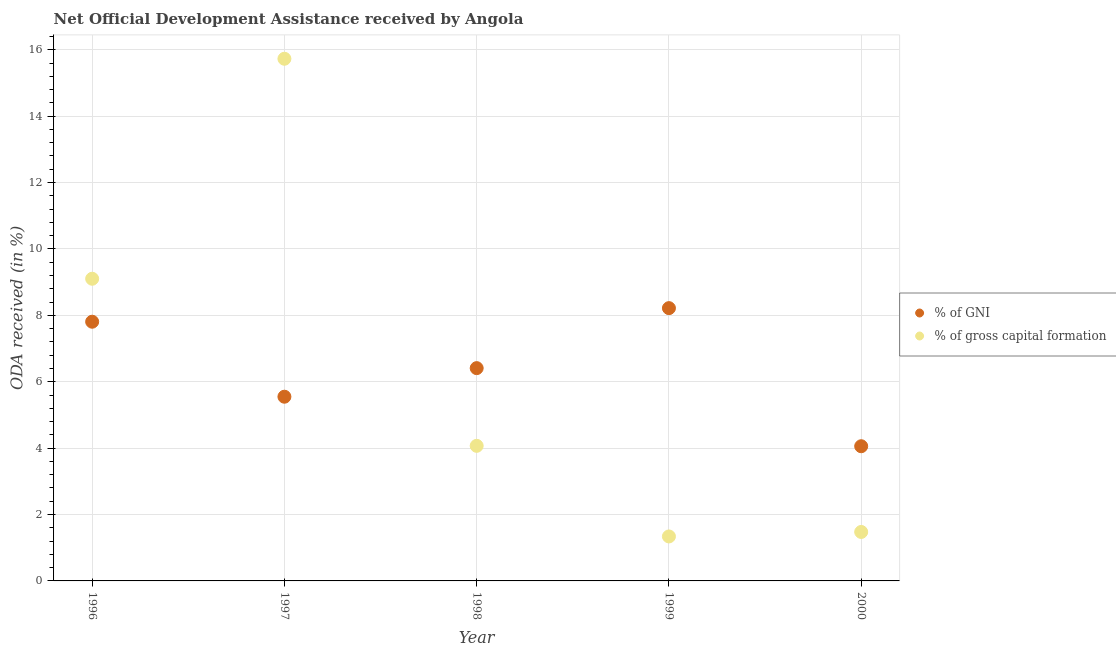What is the oda received as percentage of gross capital formation in 1996?
Provide a short and direct response. 9.1. Across all years, what is the maximum oda received as percentage of gni?
Offer a terse response. 8.22. Across all years, what is the minimum oda received as percentage of gni?
Offer a very short reply. 4.06. What is the total oda received as percentage of gni in the graph?
Keep it short and to the point. 32.04. What is the difference between the oda received as percentage of gni in 1998 and that in 1999?
Offer a very short reply. -1.81. What is the difference between the oda received as percentage of gross capital formation in 1997 and the oda received as percentage of gni in 1999?
Your answer should be compact. 7.51. What is the average oda received as percentage of gni per year?
Offer a terse response. 6.41. In the year 1998, what is the difference between the oda received as percentage of gni and oda received as percentage of gross capital formation?
Ensure brevity in your answer.  2.34. What is the ratio of the oda received as percentage of gni in 1998 to that in 1999?
Give a very brief answer. 0.78. What is the difference between the highest and the second highest oda received as percentage of gross capital formation?
Keep it short and to the point. 6.63. What is the difference between the highest and the lowest oda received as percentage of gni?
Provide a short and direct response. 4.16. In how many years, is the oda received as percentage of gross capital formation greater than the average oda received as percentage of gross capital formation taken over all years?
Your answer should be compact. 2. Is the oda received as percentage of gni strictly greater than the oda received as percentage of gross capital formation over the years?
Your answer should be very brief. No. How many years are there in the graph?
Your answer should be very brief. 5. Does the graph contain grids?
Your answer should be compact. Yes. How many legend labels are there?
Your response must be concise. 2. What is the title of the graph?
Offer a very short reply. Net Official Development Assistance received by Angola. What is the label or title of the X-axis?
Your response must be concise. Year. What is the label or title of the Y-axis?
Make the answer very short. ODA received (in %). What is the ODA received (in %) of % of GNI in 1996?
Give a very brief answer. 7.81. What is the ODA received (in %) in % of gross capital formation in 1996?
Offer a very short reply. 9.1. What is the ODA received (in %) in % of GNI in 1997?
Your response must be concise. 5.55. What is the ODA received (in %) of % of gross capital formation in 1997?
Provide a short and direct response. 15.73. What is the ODA received (in %) in % of GNI in 1998?
Provide a succinct answer. 6.41. What is the ODA received (in %) of % of gross capital formation in 1998?
Offer a very short reply. 4.07. What is the ODA received (in %) of % of GNI in 1999?
Provide a short and direct response. 8.22. What is the ODA received (in %) of % of gross capital formation in 1999?
Make the answer very short. 1.34. What is the ODA received (in %) in % of GNI in 2000?
Provide a short and direct response. 4.06. What is the ODA received (in %) of % of gross capital formation in 2000?
Give a very brief answer. 1.47. Across all years, what is the maximum ODA received (in %) in % of GNI?
Your answer should be compact. 8.22. Across all years, what is the maximum ODA received (in %) of % of gross capital formation?
Provide a succinct answer. 15.73. Across all years, what is the minimum ODA received (in %) in % of GNI?
Provide a short and direct response. 4.06. Across all years, what is the minimum ODA received (in %) in % of gross capital formation?
Keep it short and to the point. 1.34. What is the total ODA received (in %) in % of GNI in the graph?
Keep it short and to the point. 32.04. What is the total ODA received (in %) in % of gross capital formation in the graph?
Your answer should be very brief. 31.72. What is the difference between the ODA received (in %) in % of GNI in 1996 and that in 1997?
Make the answer very short. 2.26. What is the difference between the ODA received (in %) of % of gross capital formation in 1996 and that in 1997?
Your answer should be compact. -6.63. What is the difference between the ODA received (in %) in % of GNI in 1996 and that in 1998?
Provide a succinct answer. 1.4. What is the difference between the ODA received (in %) of % of gross capital formation in 1996 and that in 1998?
Provide a succinct answer. 5.03. What is the difference between the ODA received (in %) in % of GNI in 1996 and that in 1999?
Make the answer very short. -0.41. What is the difference between the ODA received (in %) in % of gross capital formation in 1996 and that in 1999?
Your answer should be compact. 7.76. What is the difference between the ODA received (in %) in % of GNI in 1996 and that in 2000?
Provide a succinct answer. 3.75. What is the difference between the ODA received (in %) in % of gross capital formation in 1996 and that in 2000?
Make the answer very short. 7.63. What is the difference between the ODA received (in %) in % of GNI in 1997 and that in 1998?
Keep it short and to the point. -0.86. What is the difference between the ODA received (in %) in % of gross capital formation in 1997 and that in 1998?
Give a very brief answer. 11.66. What is the difference between the ODA received (in %) in % of GNI in 1997 and that in 1999?
Make the answer very short. -2.67. What is the difference between the ODA received (in %) of % of gross capital formation in 1997 and that in 1999?
Provide a succinct answer. 14.39. What is the difference between the ODA received (in %) of % of GNI in 1997 and that in 2000?
Offer a terse response. 1.49. What is the difference between the ODA received (in %) in % of gross capital formation in 1997 and that in 2000?
Ensure brevity in your answer.  14.25. What is the difference between the ODA received (in %) of % of GNI in 1998 and that in 1999?
Ensure brevity in your answer.  -1.81. What is the difference between the ODA received (in %) of % of gross capital formation in 1998 and that in 1999?
Your answer should be very brief. 2.73. What is the difference between the ODA received (in %) of % of GNI in 1998 and that in 2000?
Your answer should be compact. 2.35. What is the difference between the ODA received (in %) of % of gross capital formation in 1998 and that in 2000?
Your response must be concise. 2.59. What is the difference between the ODA received (in %) of % of GNI in 1999 and that in 2000?
Provide a succinct answer. 4.16. What is the difference between the ODA received (in %) in % of gross capital formation in 1999 and that in 2000?
Provide a succinct answer. -0.14. What is the difference between the ODA received (in %) of % of GNI in 1996 and the ODA received (in %) of % of gross capital formation in 1997?
Make the answer very short. -7.92. What is the difference between the ODA received (in %) of % of GNI in 1996 and the ODA received (in %) of % of gross capital formation in 1998?
Provide a succinct answer. 3.74. What is the difference between the ODA received (in %) in % of GNI in 1996 and the ODA received (in %) in % of gross capital formation in 1999?
Your answer should be compact. 6.47. What is the difference between the ODA received (in %) of % of GNI in 1996 and the ODA received (in %) of % of gross capital formation in 2000?
Your answer should be compact. 6.33. What is the difference between the ODA received (in %) in % of GNI in 1997 and the ODA received (in %) in % of gross capital formation in 1998?
Your answer should be very brief. 1.48. What is the difference between the ODA received (in %) in % of GNI in 1997 and the ODA received (in %) in % of gross capital formation in 1999?
Offer a terse response. 4.21. What is the difference between the ODA received (in %) of % of GNI in 1997 and the ODA received (in %) of % of gross capital formation in 2000?
Provide a short and direct response. 4.07. What is the difference between the ODA received (in %) of % of GNI in 1998 and the ODA received (in %) of % of gross capital formation in 1999?
Make the answer very short. 5.07. What is the difference between the ODA received (in %) in % of GNI in 1998 and the ODA received (in %) in % of gross capital formation in 2000?
Ensure brevity in your answer.  4.93. What is the difference between the ODA received (in %) of % of GNI in 1999 and the ODA received (in %) of % of gross capital formation in 2000?
Provide a short and direct response. 6.74. What is the average ODA received (in %) in % of GNI per year?
Make the answer very short. 6.41. What is the average ODA received (in %) of % of gross capital formation per year?
Provide a short and direct response. 6.34. In the year 1996, what is the difference between the ODA received (in %) of % of GNI and ODA received (in %) of % of gross capital formation?
Ensure brevity in your answer.  -1.29. In the year 1997, what is the difference between the ODA received (in %) of % of GNI and ODA received (in %) of % of gross capital formation?
Make the answer very short. -10.18. In the year 1998, what is the difference between the ODA received (in %) of % of GNI and ODA received (in %) of % of gross capital formation?
Your answer should be very brief. 2.34. In the year 1999, what is the difference between the ODA received (in %) of % of GNI and ODA received (in %) of % of gross capital formation?
Provide a succinct answer. 6.88. In the year 2000, what is the difference between the ODA received (in %) of % of GNI and ODA received (in %) of % of gross capital formation?
Offer a very short reply. 2.58. What is the ratio of the ODA received (in %) of % of GNI in 1996 to that in 1997?
Make the answer very short. 1.41. What is the ratio of the ODA received (in %) in % of gross capital formation in 1996 to that in 1997?
Give a very brief answer. 0.58. What is the ratio of the ODA received (in %) of % of GNI in 1996 to that in 1998?
Offer a terse response. 1.22. What is the ratio of the ODA received (in %) in % of gross capital formation in 1996 to that in 1998?
Offer a terse response. 2.24. What is the ratio of the ODA received (in %) of % of GNI in 1996 to that in 1999?
Keep it short and to the point. 0.95. What is the ratio of the ODA received (in %) in % of gross capital formation in 1996 to that in 1999?
Offer a terse response. 6.79. What is the ratio of the ODA received (in %) of % of GNI in 1996 to that in 2000?
Your answer should be very brief. 1.92. What is the ratio of the ODA received (in %) of % of gross capital formation in 1996 to that in 2000?
Offer a terse response. 6.17. What is the ratio of the ODA received (in %) of % of GNI in 1997 to that in 1998?
Provide a succinct answer. 0.87. What is the ratio of the ODA received (in %) in % of gross capital formation in 1997 to that in 1998?
Your answer should be very brief. 3.87. What is the ratio of the ODA received (in %) of % of GNI in 1997 to that in 1999?
Your answer should be very brief. 0.68. What is the ratio of the ODA received (in %) of % of gross capital formation in 1997 to that in 1999?
Your answer should be compact. 11.74. What is the ratio of the ODA received (in %) of % of GNI in 1997 to that in 2000?
Keep it short and to the point. 1.37. What is the ratio of the ODA received (in %) of % of gross capital formation in 1997 to that in 2000?
Your answer should be compact. 10.67. What is the ratio of the ODA received (in %) in % of GNI in 1998 to that in 1999?
Your answer should be compact. 0.78. What is the ratio of the ODA received (in %) of % of gross capital formation in 1998 to that in 1999?
Offer a terse response. 3.04. What is the ratio of the ODA received (in %) in % of GNI in 1998 to that in 2000?
Your response must be concise. 1.58. What is the ratio of the ODA received (in %) in % of gross capital formation in 1998 to that in 2000?
Offer a terse response. 2.76. What is the ratio of the ODA received (in %) in % of GNI in 1999 to that in 2000?
Give a very brief answer. 2.03. What is the ratio of the ODA received (in %) of % of gross capital formation in 1999 to that in 2000?
Make the answer very short. 0.91. What is the difference between the highest and the second highest ODA received (in %) of % of GNI?
Your answer should be compact. 0.41. What is the difference between the highest and the second highest ODA received (in %) of % of gross capital formation?
Your response must be concise. 6.63. What is the difference between the highest and the lowest ODA received (in %) of % of GNI?
Keep it short and to the point. 4.16. What is the difference between the highest and the lowest ODA received (in %) in % of gross capital formation?
Offer a terse response. 14.39. 